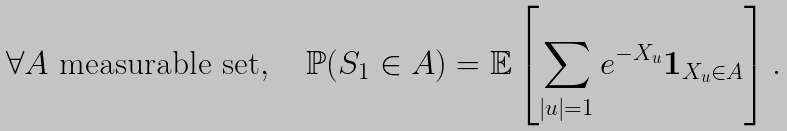Convert formula to latex. <formula><loc_0><loc_0><loc_500><loc_500>\forall A \text { measurable set} , \quad \mathbb { P } ( S _ { 1 } \in A ) = \mathbb { E } \left [ \sum _ { | u | = 1 } e ^ { - X _ { u } } \boldsymbol 1 _ { X _ { u } \in A } \right ] .</formula> 